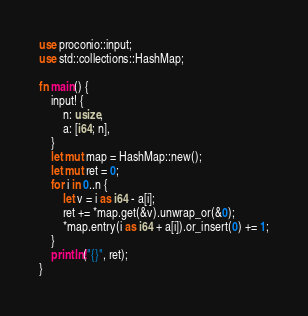<code> <loc_0><loc_0><loc_500><loc_500><_Rust_>use proconio::input;
use std::collections::HashMap;

fn main() {
    input! {
        n: usize,
        a: [i64; n],
    }
    let mut map = HashMap::new();
    let mut ret = 0;
    for i in 0..n {
        let v = i as i64 - a[i];
        ret += *map.get(&v).unwrap_or(&0);
        *map.entry(i as i64 + a[i]).or_insert(0) += 1;
    }
    println!("{}", ret);
}
</code> 